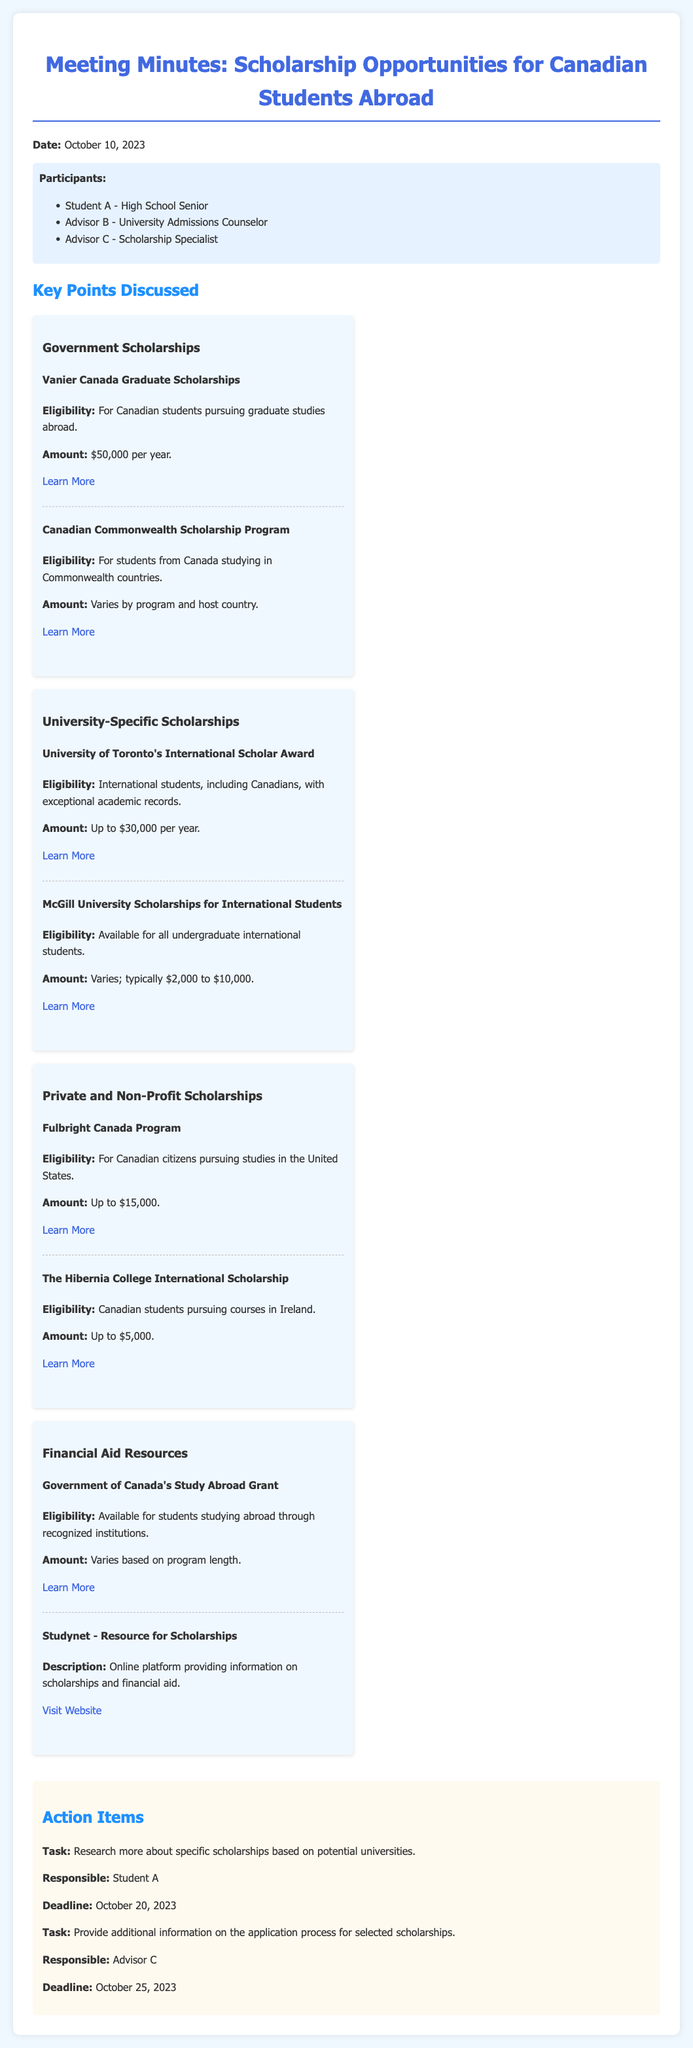what is the date of the meeting? The date of the meeting is mentioned in the document, which is October 10, 2023.
Answer: October 10, 2023 who is responsible for researching more about specific scholarships? The responsibility for this task is assigned to Student A as stated in the action items section.
Answer: Student A what is the amount of the Vanier Canada Graduate Scholarships? The document specifies the amount for this scholarship program as $50,000 per year.
Answer: $50,000 per year what is the eligibility for the Fulbright Canada Program? The eligibility for this program is stated as Canadian citizens pursuing studies in the United States.
Answer: Canadian citizens pursuing studies in the United States how much can students receive from the Government of Canada's Study Abroad Grant? The grant amount is said to vary based on program length, indicating there is no fixed amount provided.
Answer: Varies based on program length what is the deadline for providing additional information on scholarships? The deadline for this action item is mentioned in the document as October 25, 2023.
Answer: October 25, 2023 how many participants were present at the meeting? The participants list includes three individuals, which is provided in the document.
Answer: Three what type of document is this? The structure and content suggest that this is a record of a meeting that discussed scholarship opportunities.
Answer: Meeting minutes what is the main topic discussed in the meeting? The main topic revolves around scholarship and financial aid opportunities for Canadian students studying abroad.
Answer: Scholarship and financial aid opportunities 